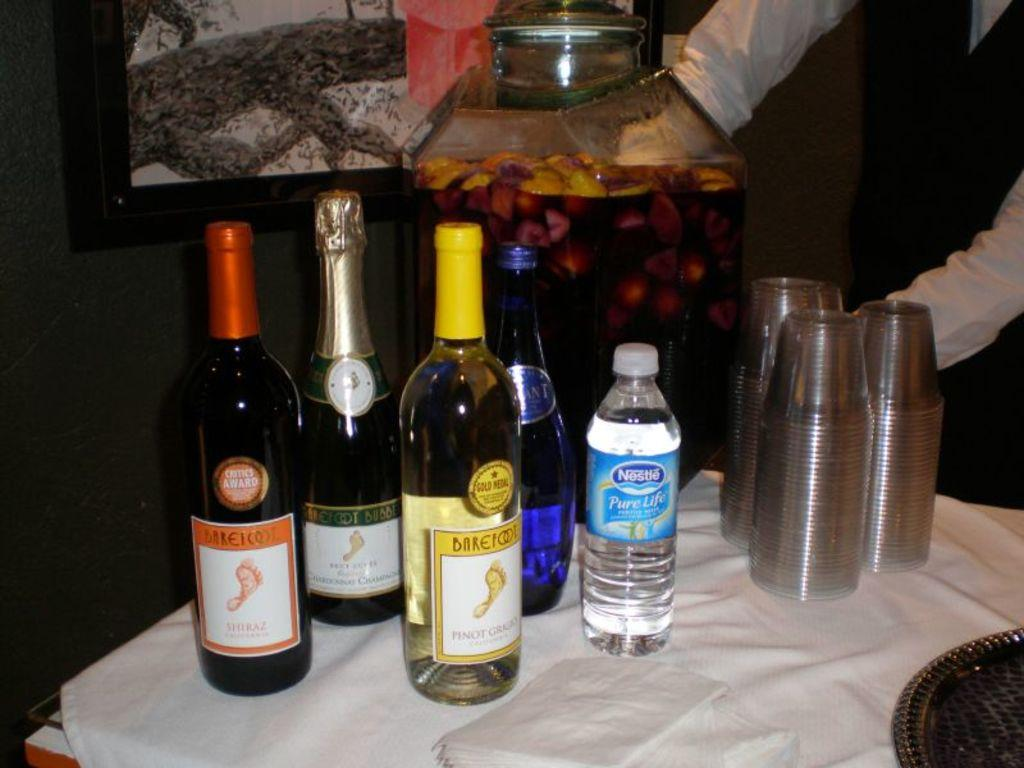<image>
Write a terse but informative summary of the picture. a Nestle bottle that is on a white sheet 